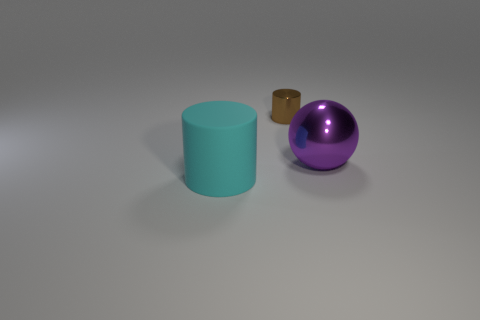What number of other objects are there of the same shape as the big cyan object?
Your answer should be compact. 1. What is the shape of the cyan object?
Keep it short and to the point. Cylinder. Are any purple rubber blocks visible?
Provide a succinct answer. No. There is a thing that is on the left side of the large sphere and behind the large matte thing; what size is it?
Your answer should be very brief. Small. Are there more purple shiny objects behind the big cyan thing than purple things that are to the left of the shiny cylinder?
Your answer should be compact. Yes. What is the color of the ball?
Offer a terse response. Purple. There is a thing that is both on the right side of the cyan matte cylinder and in front of the small object; what color is it?
Give a very brief answer. Purple. What is the color of the cylinder that is in front of the cylinder behind the cylinder on the left side of the brown shiny cylinder?
Provide a short and direct response. Cyan. What color is the cylinder that is the same size as the purple metal thing?
Give a very brief answer. Cyan. What shape is the large object that is on the right side of the cylinder on the left side of the thing behind the ball?
Make the answer very short. Sphere. 